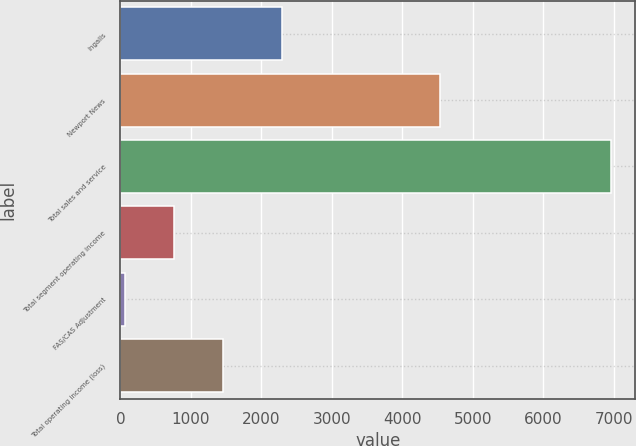Convert chart. <chart><loc_0><loc_0><loc_500><loc_500><bar_chart><fcel>Ingalls<fcel>Newport News<fcel>Total sales and service<fcel>Total segment operating income<fcel>FAS/CAS Adjustment<fcel>Total operating income (loss)<nl><fcel>2286<fcel>4536<fcel>6957<fcel>760.5<fcel>72<fcel>1449<nl></chart> 